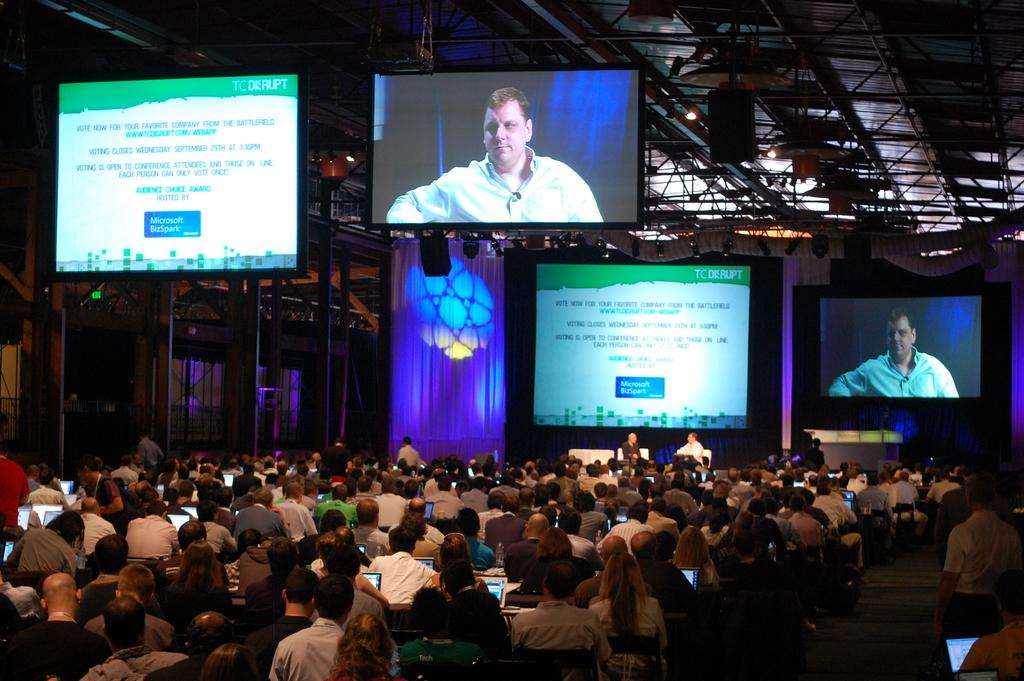Provide a one-sentence caption for the provided image. The two television screens above a large group of people talks about Microsoft. 